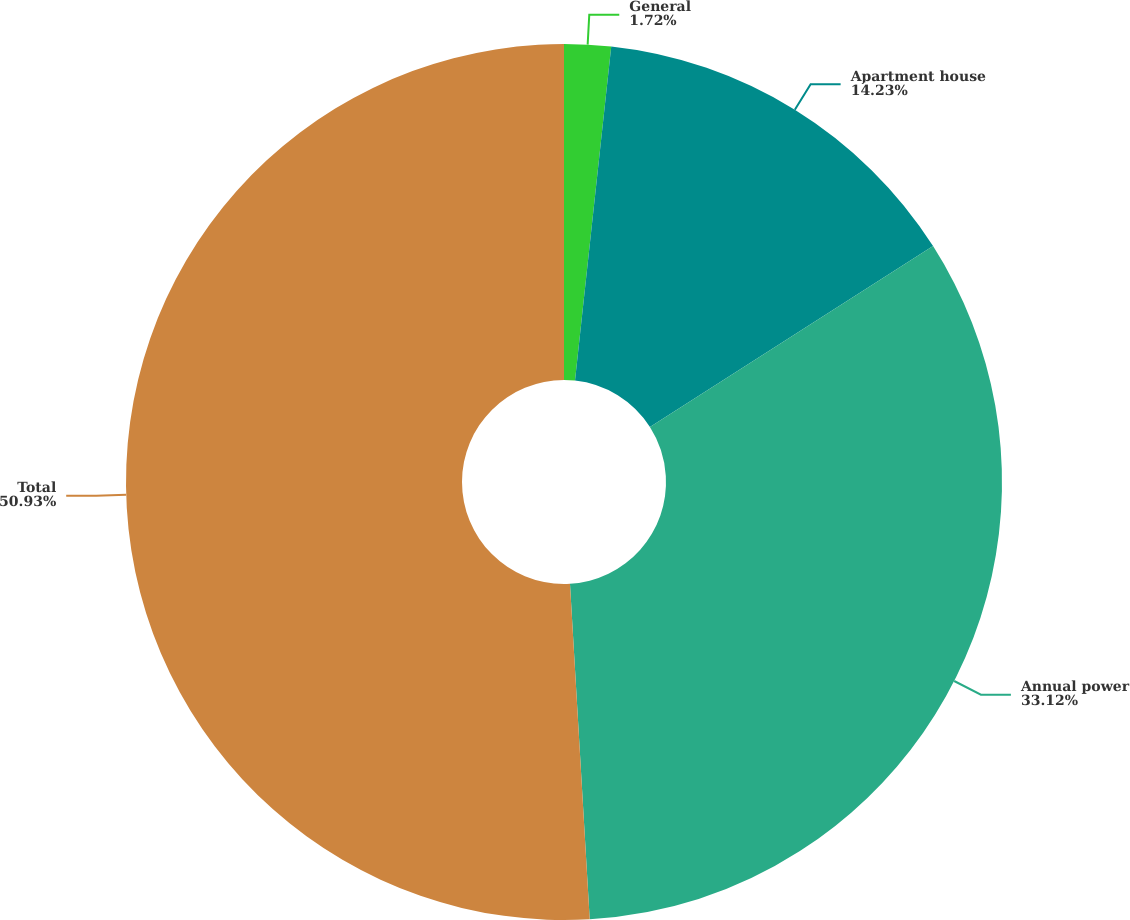Convert chart. <chart><loc_0><loc_0><loc_500><loc_500><pie_chart><fcel>General<fcel>Apartment house<fcel>Annual power<fcel>Total<nl><fcel>1.72%<fcel>14.23%<fcel>33.12%<fcel>50.94%<nl></chart> 